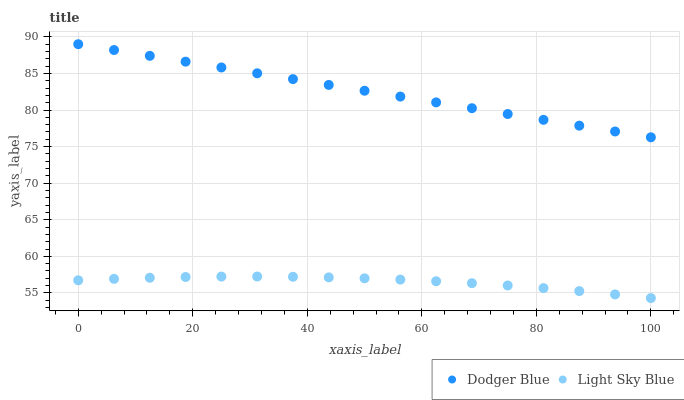Does Light Sky Blue have the minimum area under the curve?
Answer yes or no. Yes. Does Dodger Blue have the maximum area under the curve?
Answer yes or no. Yes. Does Dodger Blue have the minimum area under the curve?
Answer yes or no. No. Is Dodger Blue the smoothest?
Answer yes or no. Yes. Is Light Sky Blue the roughest?
Answer yes or no. Yes. Is Dodger Blue the roughest?
Answer yes or no. No. Does Light Sky Blue have the lowest value?
Answer yes or no. Yes. Does Dodger Blue have the lowest value?
Answer yes or no. No. Does Dodger Blue have the highest value?
Answer yes or no. Yes. Is Light Sky Blue less than Dodger Blue?
Answer yes or no. Yes. Is Dodger Blue greater than Light Sky Blue?
Answer yes or no. Yes. Does Light Sky Blue intersect Dodger Blue?
Answer yes or no. No. 